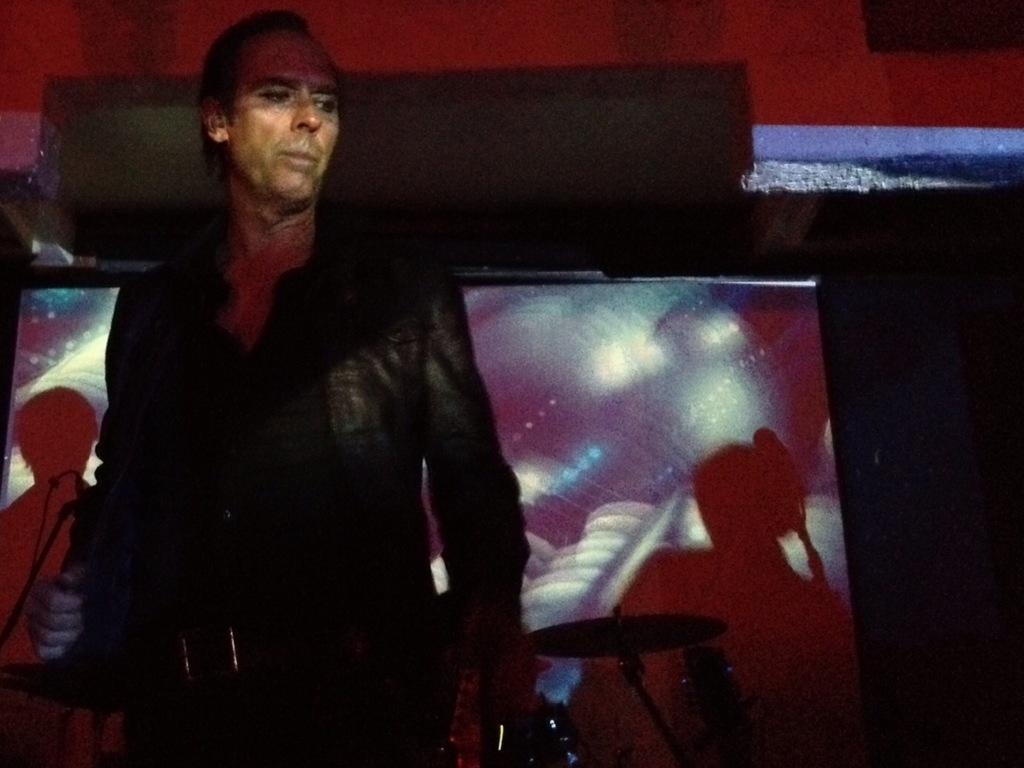What is the man in the image wearing? The man in the image is wearing a black jacket. What can be seen in the background of the image? There is a screen and musical instruments in the background of the image. What type of sack is the man carrying on the sidewalk in the image? There is no sack or sidewalk present in the image. 